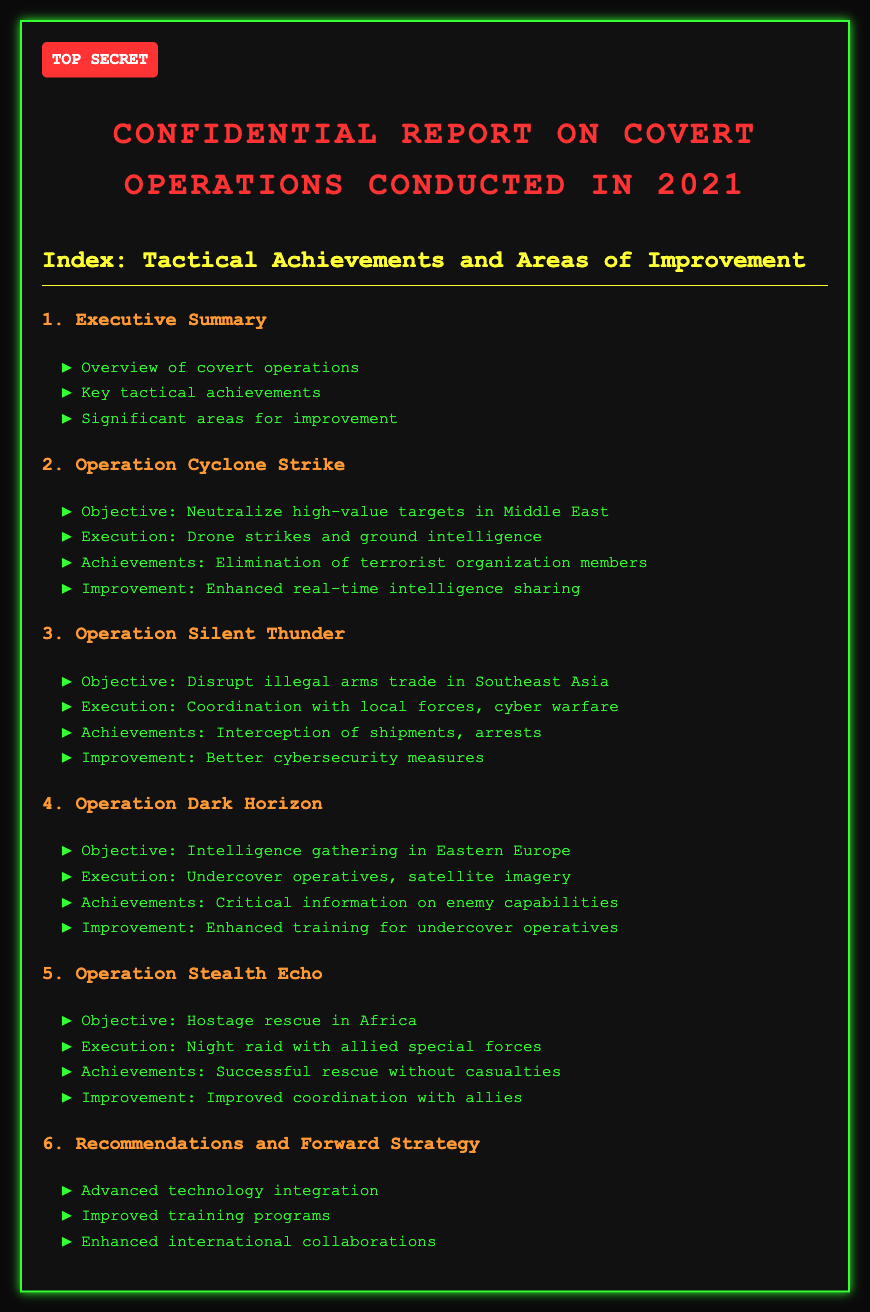what is the title of the report? The title of the report is located at the top in bold letters, summarizing the focus of the document.
Answer: Confidential Report on Covert Operations Conducted in 2021 how many operations are detailed in the report? The report outlines five specific operations, as listed in the index.
Answer: four what was the objective of Operation Silent Thunder? The objective of Operation Silent Thunder is explicitly stated in the section detailing the operation.
Answer: Disrupt illegal arms trade in Southeast Asia what improvement is suggested for Operation Cyclone Strike? The recommended area for improvement in Operation Cyclone Strike is specified in the respective section of the document.
Answer: Enhanced real-time intelligence sharing which operation involved a hostage rescue? The operation that focuses on a hostage rescue is explicitly named in the index.
Answer: Operation Stealth Echo what execution method was used in Operation Dark Horizon? The execution method for Operation Dark Horizon is outlined within that operation's details in the report.
Answer: Undercover operatives, satellite imagery what is a key recommendation in the report? The recommendations and forward strategy section lists various suggestions, focusing on improvements.
Answer: Advanced technology integration 